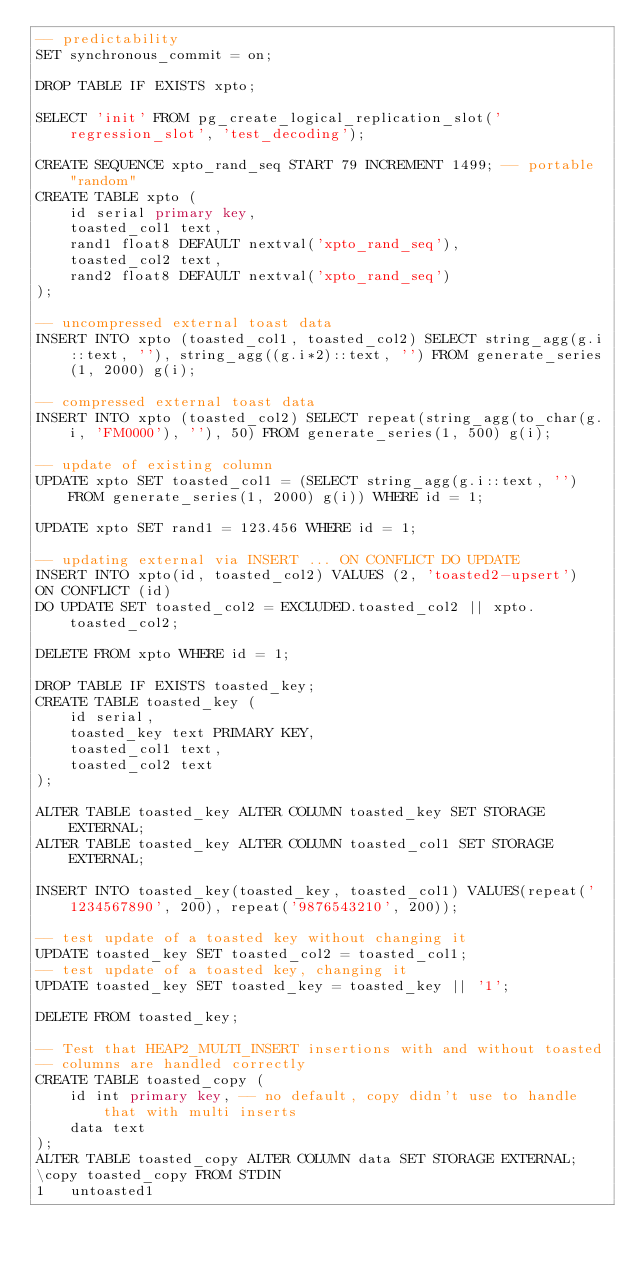Convert code to text. <code><loc_0><loc_0><loc_500><loc_500><_SQL_>-- predictability
SET synchronous_commit = on;

DROP TABLE IF EXISTS xpto;

SELECT 'init' FROM pg_create_logical_replication_slot('regression_slot', 'test_decoding');

CREATE SEQUENCE xpto_rand_seq START 79 INCREMENT 1499; -- portable "random"
CREATE TABLE xpto (
    id serial primary key,
    toasted_col1 text,
    rand1 float8 DEFAULT nextval('xpto_rand_seq'),
    toasted_col2 text,
    rand2 float8 DEFAULT nextval('xpto_rand_seq')
);

-- uncompressed external toast data
INSERT INTO xpto (toasted_col1, toasted_col2) SELECT string_agg(g.i::text, ''), string_agg((g.i*2)::text, '') FROM generate_series(1, 2000) g(i);

-- compressed external toast data
INSERT INTO xpto (toasted_col2) SELECT repeat(string_agg(to_char(g.i, 'FM0000'), ''), 50) FROM generate_series(1, 500) g(i);

-- update of existing column
UPDATE xpto SET toasted_col1 = (SELECT string_agg(g.i::text, '') FROM generate_series(1, 2000) g(i)) WHERE id = 1;

UPDATE xpto SET rand1 = 123.456 WHERE id = 1;

-- updating external via INSERT ... ON CONFLICT DO UPDATE
INSERT INTO xpto(id, toasted_col2) VALUES (2, 'toasted2-upsert')
ON CONFLICT (id)
DO UPDATE SET toasted_col2 = EXCLUDED.toasted_col2 || xpto.toasted_col2;

DELETE FROM xpto WHERE id = 1;

DROP TABLE IF EXISTS toasted_key;
CREATE TABLE toasted_key (
    id serial,
    toasted_key text PRIMARY KEY,
    toasted_col1 text,
    toasted_col2 text
);

ALTER TABLE toasted_key ALTER COLUMN toasted_key SET STORAGE EXTERNAL;
ALTER TABLE toasted_key ALTER COLUMN toasted_col1 SET STORAGE EXTERNAL;

INSERT INTO toasted_key(toasted_key, toasted_col1) VALUES(repeat('1234567890', 200), repeat('9876543210', 200));

-- test update of a toasted key without changing it
UPDATE toasted_key SET toasted_col2 = toasted_col1;
-- test update of a toasted key, changing it
UPDATE toasted_key SET toasted_key = toasted_key || '1';

DELETE FROM toasted_key;

-- Test that HEAP2_MULTI_INSERT insertions with and without toasted
-- columns are handled correctly
CREATE TABLE toasted_copy (
    id int primary key, -- no default, copy didn't use to handle that with multi inserts
    data text
);
ALTER TABLE toasted_copy ALTER COLUMN data SET STORAGE EXTERNAL;
\copy toasted_copy FROM STDIN
1	untoasted1</code> 